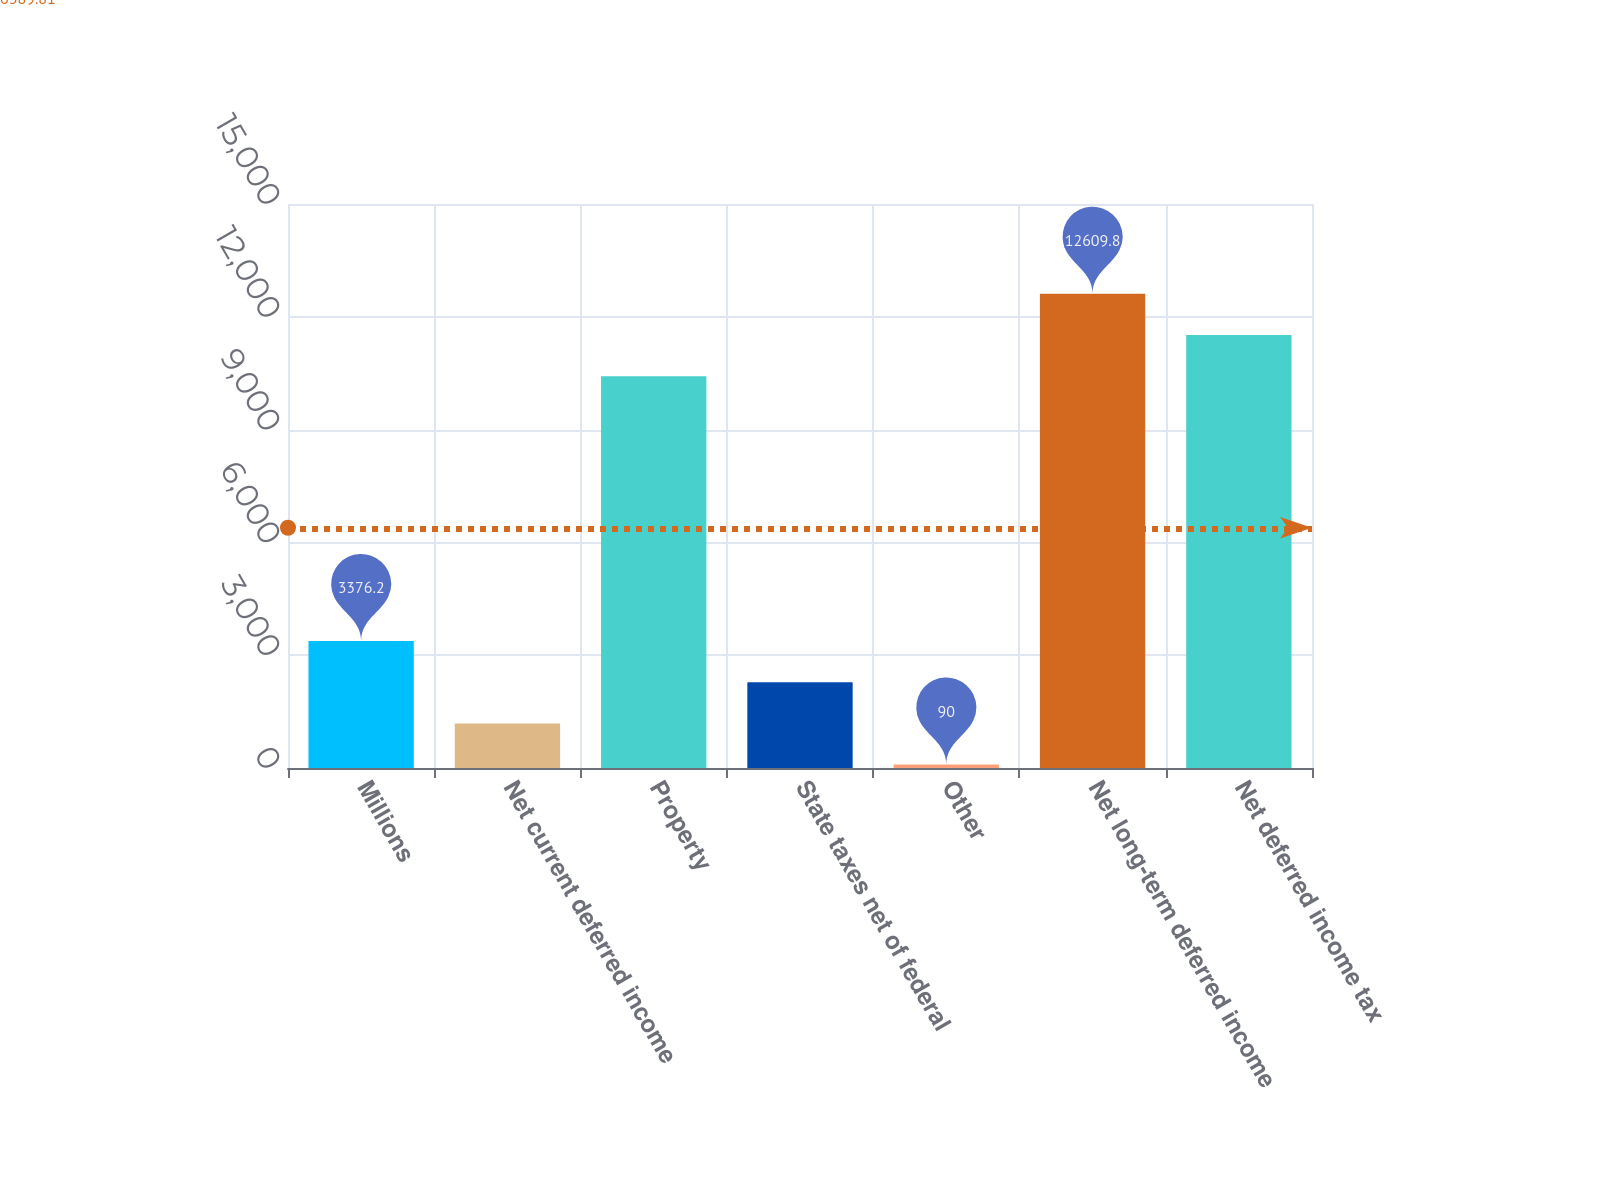Convert chart to OTSL. <chart><loc_0><loc_0><loc_500><loc_500><bar_chart><fcel>Millions<fcel>Net current deferred income<fcel>Property<fcel>State taxes net of federal<fcel>Other<fcel>Net long-term deferred income<fcel>Net deferred income tax<nl><fcel>3376.2<fcel>1185.4<fcel>10419<fcel>2280.8<fcel>90<fcel>12609.8<fcel>11514.4<nl></chart> 